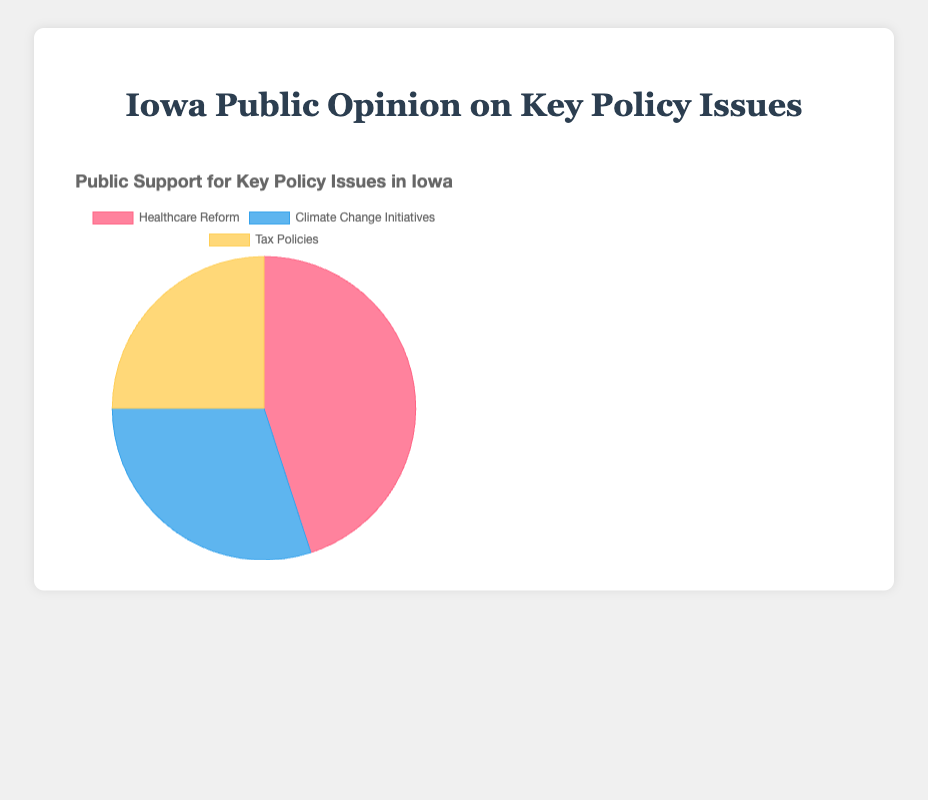What percentage of the public supports Healthcare Reform policies compared to Climate Change Initiatives? Healthcare Reform has 45% support, and Climate Change Initiatives have 30% support. Comparing these values, Healthcare Reform has a higher support percentage by 15%.
Answer: Healthcare Reform by 15% Which policy issue has the lowest public support? By observing the data, Tax Policies have the lowest percentage of public support at 25%, as compared to 45% for Healthcare Reform and 30% for Climate Change Initiatives.
Answer: Tax Policies By how much does the support for Healthcare Reform exceed Tax Policies? Healthcare Reform has 45% support, and Tax Policies have 25% support. The difference in support is 45% - 25% = 20%.
Answer: 20% Which policy issue is represented by the blue section of the pie chart? The blue section represents Climate Change Initiatives, as the background color associated with Climate Change Initiatives is labeled in blue in the data.
Answer: Climate Change Initiatives What is the total percentage of support for Climate Change Initiatives and Tax Policies combined? Climate Change Initiatives have 30% support, and Tax Policies have 25%. Adding these together gives 30% + 25% = 55%.
Answer: 55% What is the mean support for all three policy issues? The support percentages are 45% for Healthcare Reform, 30% for Climate Change Initiatives, and 25% for Tax Policies. Adding these gives 45 + 30 + 25 = 100 and then dividing by 3 provides the mean: 100 / 3 ≈ 33.33%.
Answer: 33.33% Which sections of the pie chart are larger than the section representing Tax Policies? The sections for Healthcare Reform (45%) and Climate Change Initiatives (30%) are larger than the section for Tax Policies which is at 25%.
Answer: Healthcare Reform, Climate Change Initiatives Comparing Healthcare Reform to Climate Change Initiatives, which one has a wider support margin and by how much? Healthcare Reform has 45% support, and Climate Change Initiatives have 30%. The margin is 45% - 30% = 15%.
Answer: Healthcare Reform by 15% 